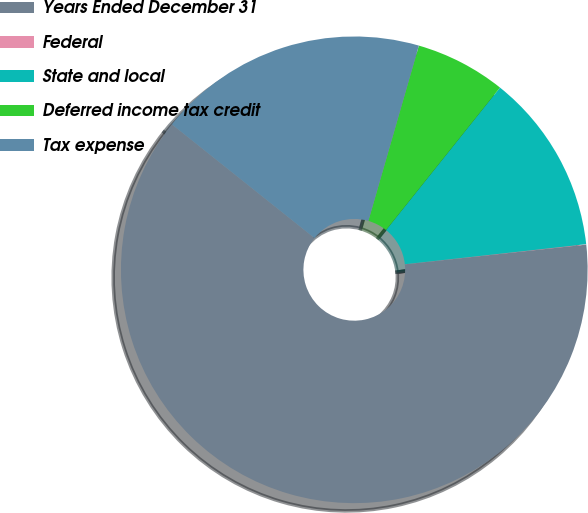Convert chart to OTSL. <chart><loc_0><loc_0><loc_500><loc_500><pie_chart><fcel>Years Ended December 31<fcel>Federal<fcel>State and local<fcel>Deferred income tax credit<fcel>Tax expense<nl><fcel>62.43%<fcel>0.03%<fcel>12.51%<fcel>6.27%<fcel>18.75%<nl></chart> 